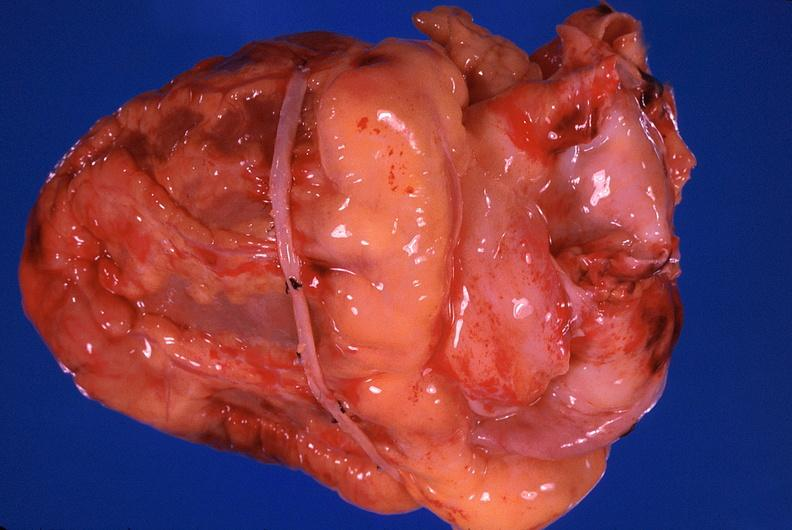s surface present?
Answer the question using a single word or phrase. No 